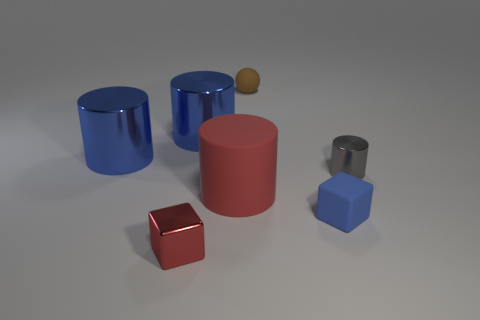Add 2 tiny metal cylinders. How many objects exist? 9 Subtract all gray cylinders. How many cylinders are left? 3 Subtract all gray cylinders. How many cylinders are left? 3 Subtract 1 cubes. How many cubes are left? 1 Add 5 big red things. How many big red things are left? 6 Add 6 big red objects. How many big red objects exist? 7 Subtract 0 gray spheres. How many objects are left? 7 Subtract all balls. How many objects are left? 6 Subtract all gray cylinders. Subtract all red spheres. How many cylinders are left? 3 Subtract all gray spheres. How many cyan cylinders are left? 0 